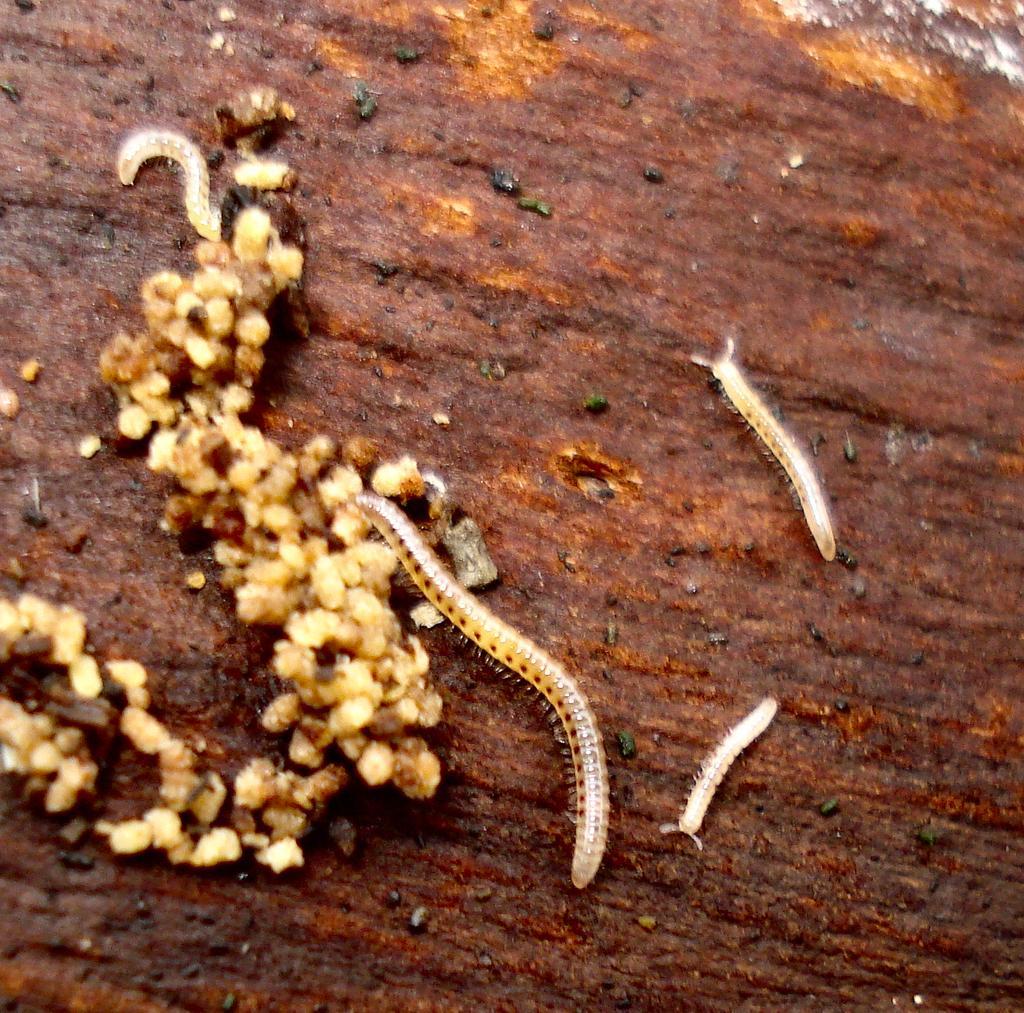Describe this image in one or two sentences. In the image we can see there are worms which are lying on the ground. 